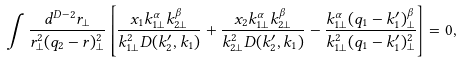<formula> <loc_0><loc_0><loc_500><loc_500>\int \frac { d ^ { D - 2 } r _ { \perp } } { r _ { \perp } ^ { 2 } ( q _ { 2 } - r ) _ { \perp } ^ { 2 } } \left [ \frac { x _ { 1 } k _ { 1 \perp } ^ { \alpha } k _ { 2 \perp } ^ { \beta } } { k _ { 1 \perp } ^ { 2 } D ( k _ { 2 } ^ { \prime } , k _ { 1 } ) } + \frac { x _ { 2 } k _ { 1 \perp } ^ { \alpha } k _ { 2 \perp } ^ { \beta } } { k _ { 2 \perp } ^ { 2 } D ( k _ { 2 } ^ { \prime } , k _ { 1 } ) } - \frac { k _ { 1 \perp } ^ { \alpha } ( q _ { 1 } - k _ { 1 } ^ { \prime } ) _ { \perp } ^ { \beta } } { k _ { 1 \perp } ^ { 2 } ( q _ { 1 } - k _ { 1 } ^ { \prime } ) _ { \perp } ^ { 2 } } \right ] = 0 ,</formula> 